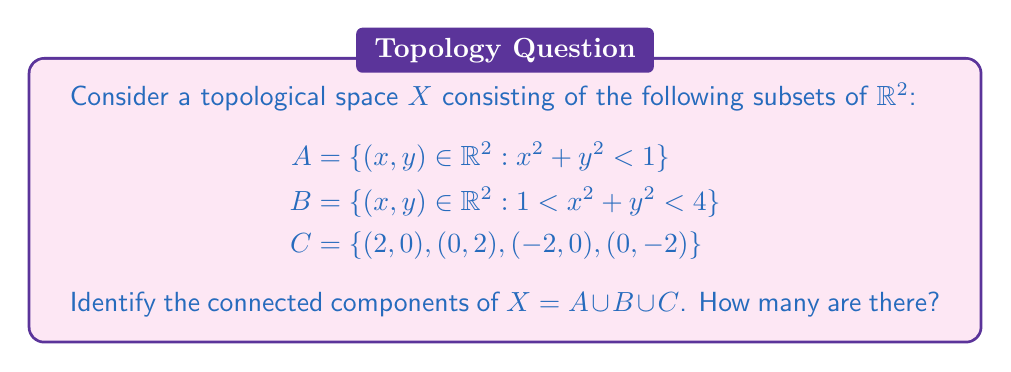Show me your answer to this math problem. Let's approach this step-by-step:

1) First, let's visualize the space:
   - $A$ is an open unit disk centered at the origin
   - $B$ is an open annulus (ring) with inner radius 1 and outer radius 2
   - $C$ consists of four isolated points on the coordinate axes at distance 2 from the origin

2) To identify connected components, we need to find maximal connected subsets of $X$.

3) $A$ is connected because it's an open disk. It forms one connected component.

4) $B$ is also connected because it's an open annulus. It forms another connected component.

5) $A$ and $B$ are not connected to each other because there's a gap between them (the unit circle).

6) The four points in $C$ are isolated:
   - They're not in $A$ or $B$ (check: $2^2 + 0^2 = 4$, which is not < 1 or between 1 and 4)
   - They're not connected to each other or to $A$ or $B$

7) Therefore, each point in $C$ forms its own connected component.

In total, we have:
- 1 component for $A$
- 1 component for $B$
- 4 components for the four points in $C$
Answer: The topological space $X$ has 6 connected components. 